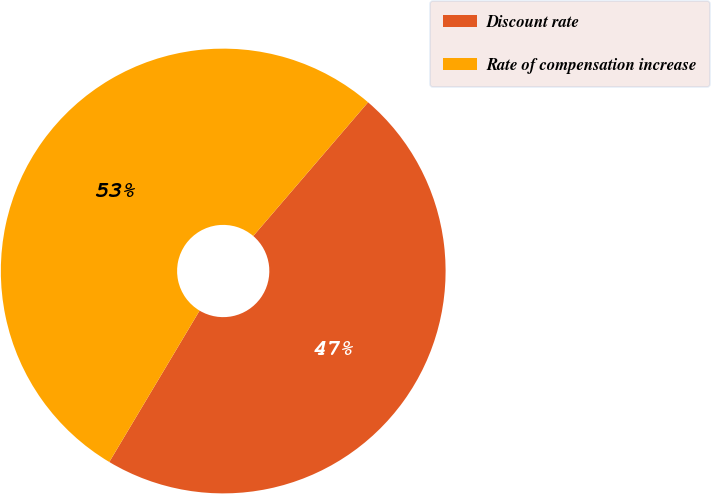Convert chart to OTSL. <chart><loc_0><loc_0><loc_500><loc_500><pie_chart><fcel>Discount rate<fcel>Rate of compensation increase<nl><fcel>47.27%<fcel>52.73%<nl></chart> 